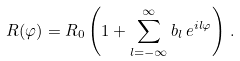Convert formula to latex. <formula><loc_0><loc_0><loc_500><loc_500>R ( \varphi ) = R _ { 0 } \left ( 1 + \sum _ { l = - \infty } ^ { \infty } b _ { l } \, e ^ { i l \varphi } \right ) \, .</formula> 